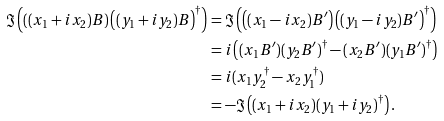Convert formula to latex. <formula><loc_0><loc_0><loc_500><loc_500>\Im \left ( \left ( ( x _ { 1 } + i x _ { 2 } ) B \right ) \left ( ( y _ { 1 } + i y _ { 2 } ) B \right ) ^ { \dagger } \right ) & = \Im \left ( \left ( ( x _ { 1 } - i x _ { 2 } ) B ^ { \prime } \right ) \left ( ( y _ { 1 } - i y _ { 2 } ) B ^ { \prime } \right ) ^ { \dagger } \right ) \\ & = i \left ( ( x _ { 1 } B ^ { \prime } ) ( y _ { 2 } B ^ { \prime } ) ^ { \dagger } - ( x _ { 2 } B ^ { \prime } ) ( y _ { 1 } B ^ { \prime } ) ^ { \dagger } \right ) \\ & = i ( x _ { 1 } y _ { 2 } ^ { \dagger } - x _ { 2 } y _ { 1 } ^ { \dagger } ) \\ & = - \Im \left ( ( x _ { 1 } + i x _ { 2 } ) ( y _ { 1 } + i y _ { 2 } ) ^ { \dagger } \right ) .</formula> 